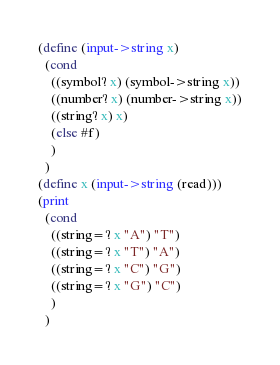Convert code to text. <code><loc_0><loc_0><loc_500><loc_500><_Scheme_>(define (input->string x)
  (cond
    ((symbol? x) (symbol->string x))
    ((number? x) (number->string x))
    ((string? x) x)
    (else #f)
    )
  )
(define x (input->string (read)))
(print
  (cond
    ((string=? x "A") "T")
    ((string=? x "T") "A")
    ((string=? x "C") "G")
    ((string=? x "G") "C")
    )
  )</code> 